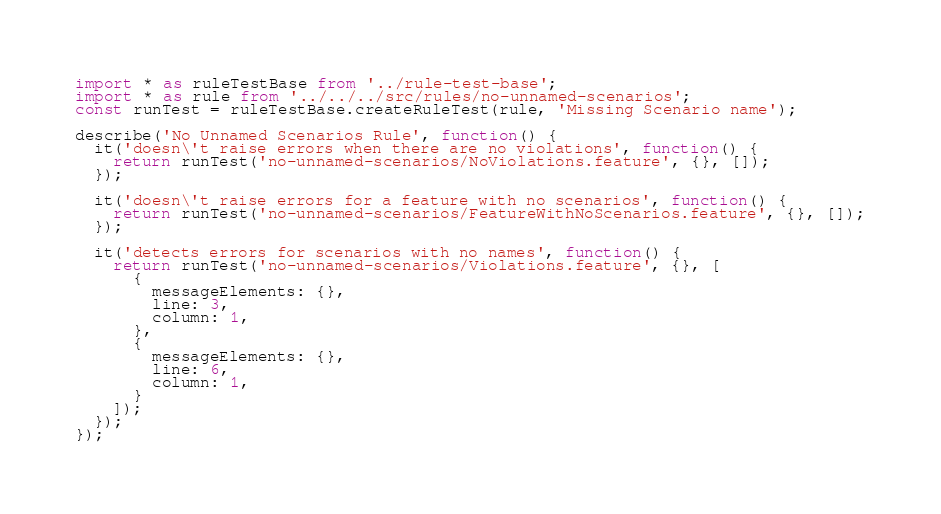Convert code to text. <code><loc_0><loc_0><loc_500><loc_500><_TypeScript_>import * as ruleTestBase from '../rule-test-base';
import * as rule from '../../../src/rules/no-unnamed-scenarios';
const runTest = ruleTestBase.createRuleTest(rule, 'Missing Scenario name');

describe('No Unnamed Scenarios Rule', function() {
  it('doesn\'t raise errors when there are no violations', function() {
    return runTest('no-unnamed-scenarios/NoViolations.feature', {}, []);
  });

  it('doesn\'t raise errors for a feature with no scenarios', function() {
    return runTest('no-unnamed-scenarios/FeatureWithNoScenarios.feature', {}, []);
  });

  it('detects errors for scenarios with no names', function() {
    return runTest('no-unnamed-scenarios/Violations.feature', {}, [
      {
        messageElements: {},
        line: 3,
        column: 1,
      },
      {
        messageElements: {},
        line: 6,
        column: 1,
      }
    ]);
  });
});
</code> 